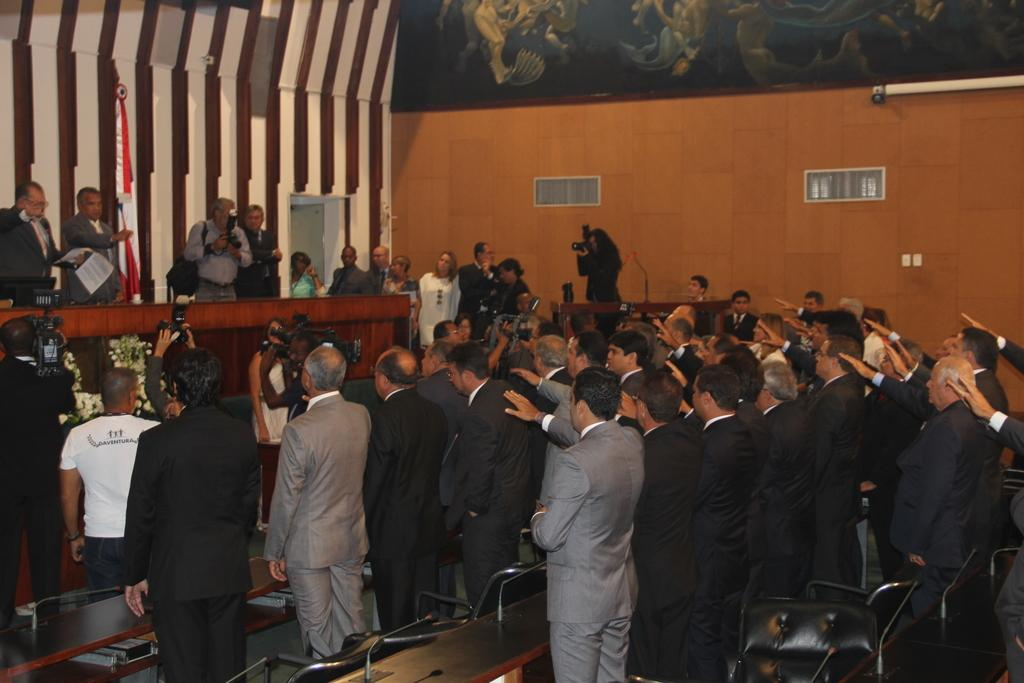How many people are in the group visible in the image? There is a group of people standing in the image, but the exact number cannot be determined from the provided facts. What type of furniture is present in the image? There are chairs and tables in the image. What equipment is being used by some people in the image? There are microphones (mikes) in the image, and some people are holding cameras. What decorative items can be seen in the image? There are flower bouquets in the image. What is attached to the wall in the image? There is a frame attached to the wall in the image. What type of identification is visible in the image? There are badges in the image. How many apples are on the table in the image? There is no mention of apples in the provided facts, so we cannot determine if any apples are present in the image. What type of cloth is draped over the chairs in the image? There is no mention of cloth or any fabric covering the chairs in the provided facts, so we cannot determine if any cloth is present in the image. 